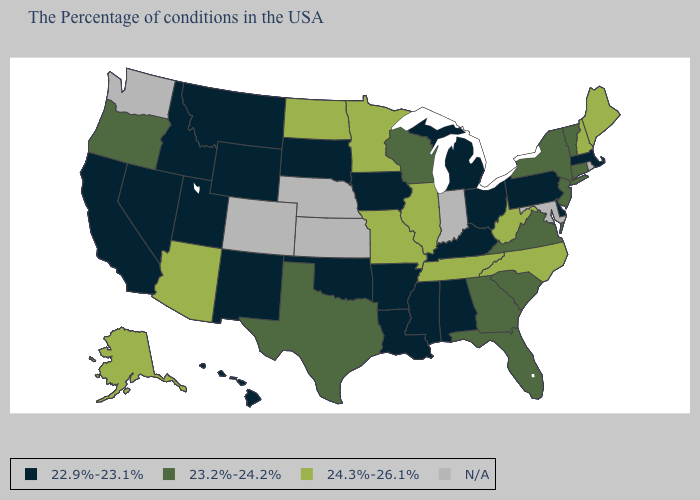What is the value of Oregon?
Answer briefly. 23.2%-24.2%. What is the lowest value in the Northeast?
Be succinct. 22.9%-23.1%. What is the value of Pennsylvania?
Short answer required. 22.9%-23.1%. What is the value of Colorado?
Answer briefly. N/A. Which states have the lowest value in the USA?
Concise answer only. Massachusetts, Delaware, Pennsylvania, Ohio, Michigan, Kentucky, Alabama, Mississippi, Louisiana, Arkansas, Iowa, Oklahoma, South Dakota, Wyoming, New Mexico, Utah, Montana, Idaho, Nevada, California, Hawaii. Does New Jersey have the lowest value in the USA?
Answer briefly. No. Which states have the highest value in the USA?
Short answer required. Maine, New Hampshire, North Carolina, West Virginia, Tennessee, Illinois, Missouri, Minnesota, North Dakota, Arizona, Alaska. What is the value of Oregon?
Answer briefly. 23.2%-24.2%. What is the highest value in the West ?
Give a very brief answer. 24.3%-26.1%. Name the states that have a value in the range 24.3%-26.1%?
Write a very short answer. Maine, New Hampshire, North Carolina, West Virginia, Tennessee, Illinois, Missouri, Minnesota, North Dakota, Arizona, Alaska. What is the highest value in states that border Illinois?
Answer briefly. 24.3%-26.1%. Does Kentucky have the lowest value in the USA?
Answer briefly. Yes. 